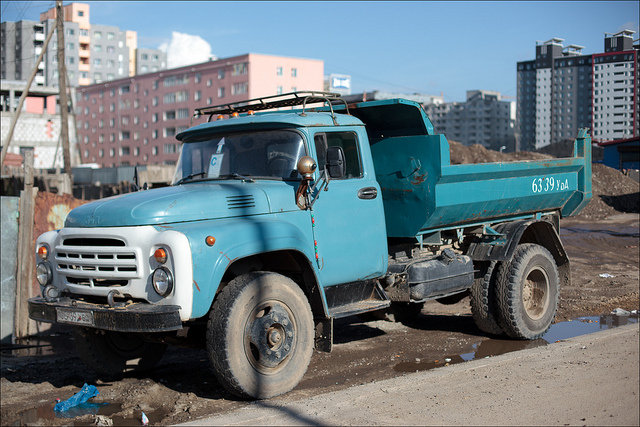Read and extract the text from this image. 6339 